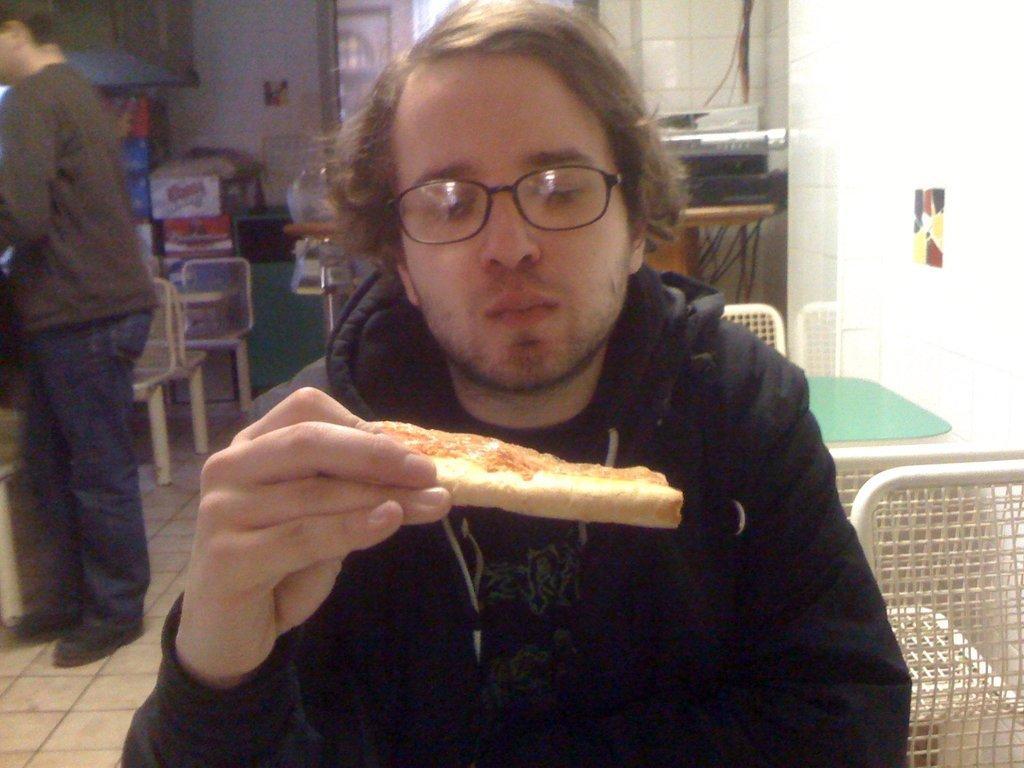Describe this image in one or two sentences. In this image there is a man in the middle who is sitting on the chair by holding the pizza. Behind him there is another person who is standing on the floor. In the background there are tables and chairs. On the left side, there are books kept one after the other on the chair. In the background there are windows. 